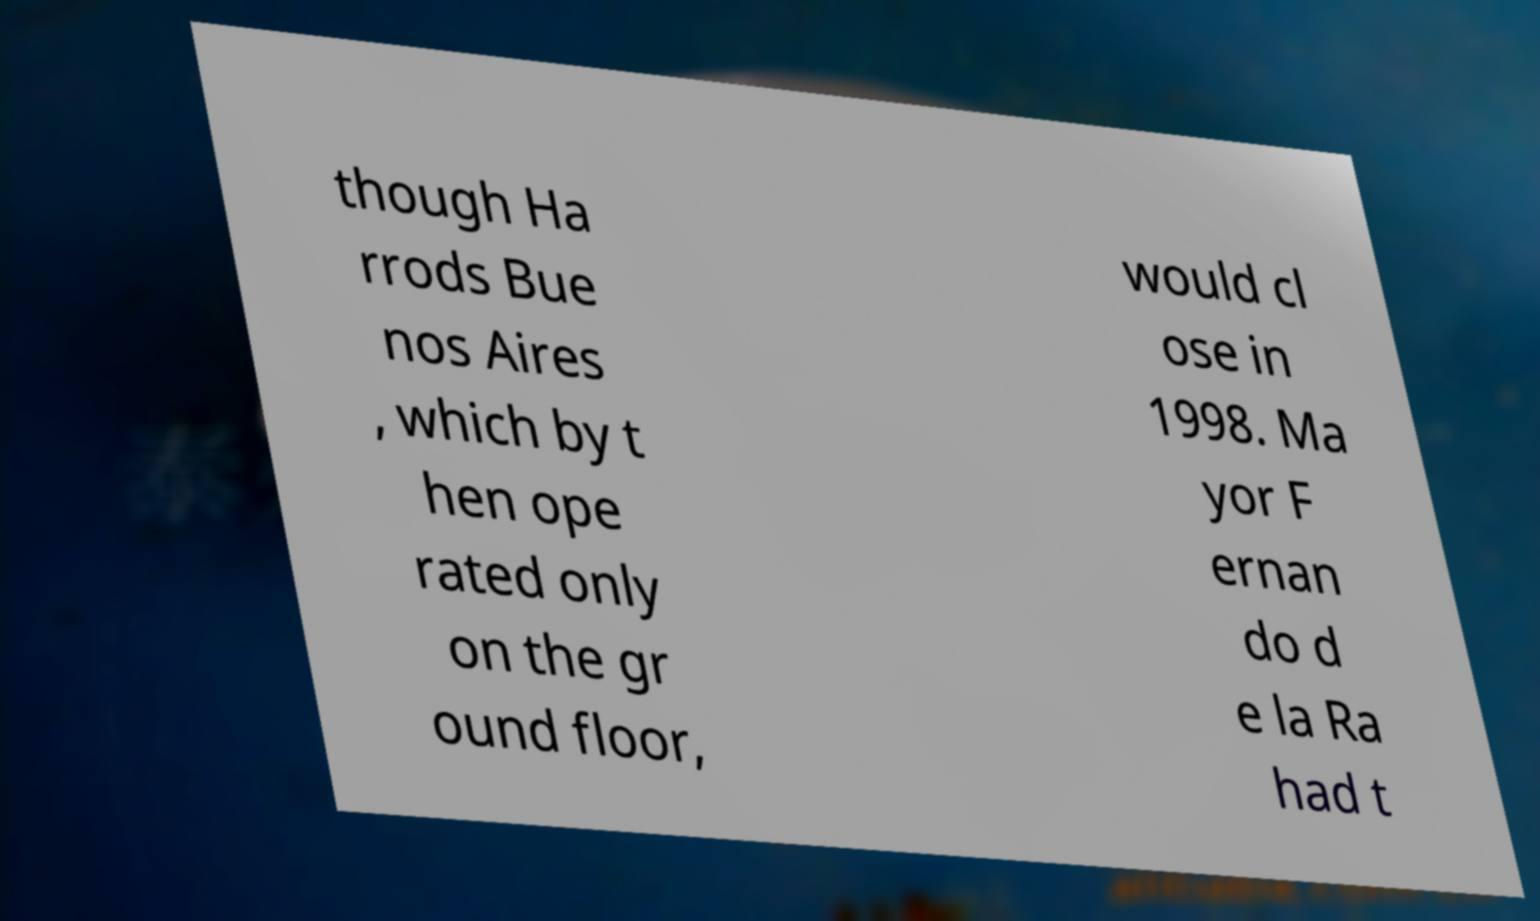Can you accurately transcribe the text from the provided image for me? though Ha rrods Bue nos Aires , which by t hen ope rated only on the gr ound floor, would cl ose in 1998. Ma yor F ernan do d e la Ra had t 